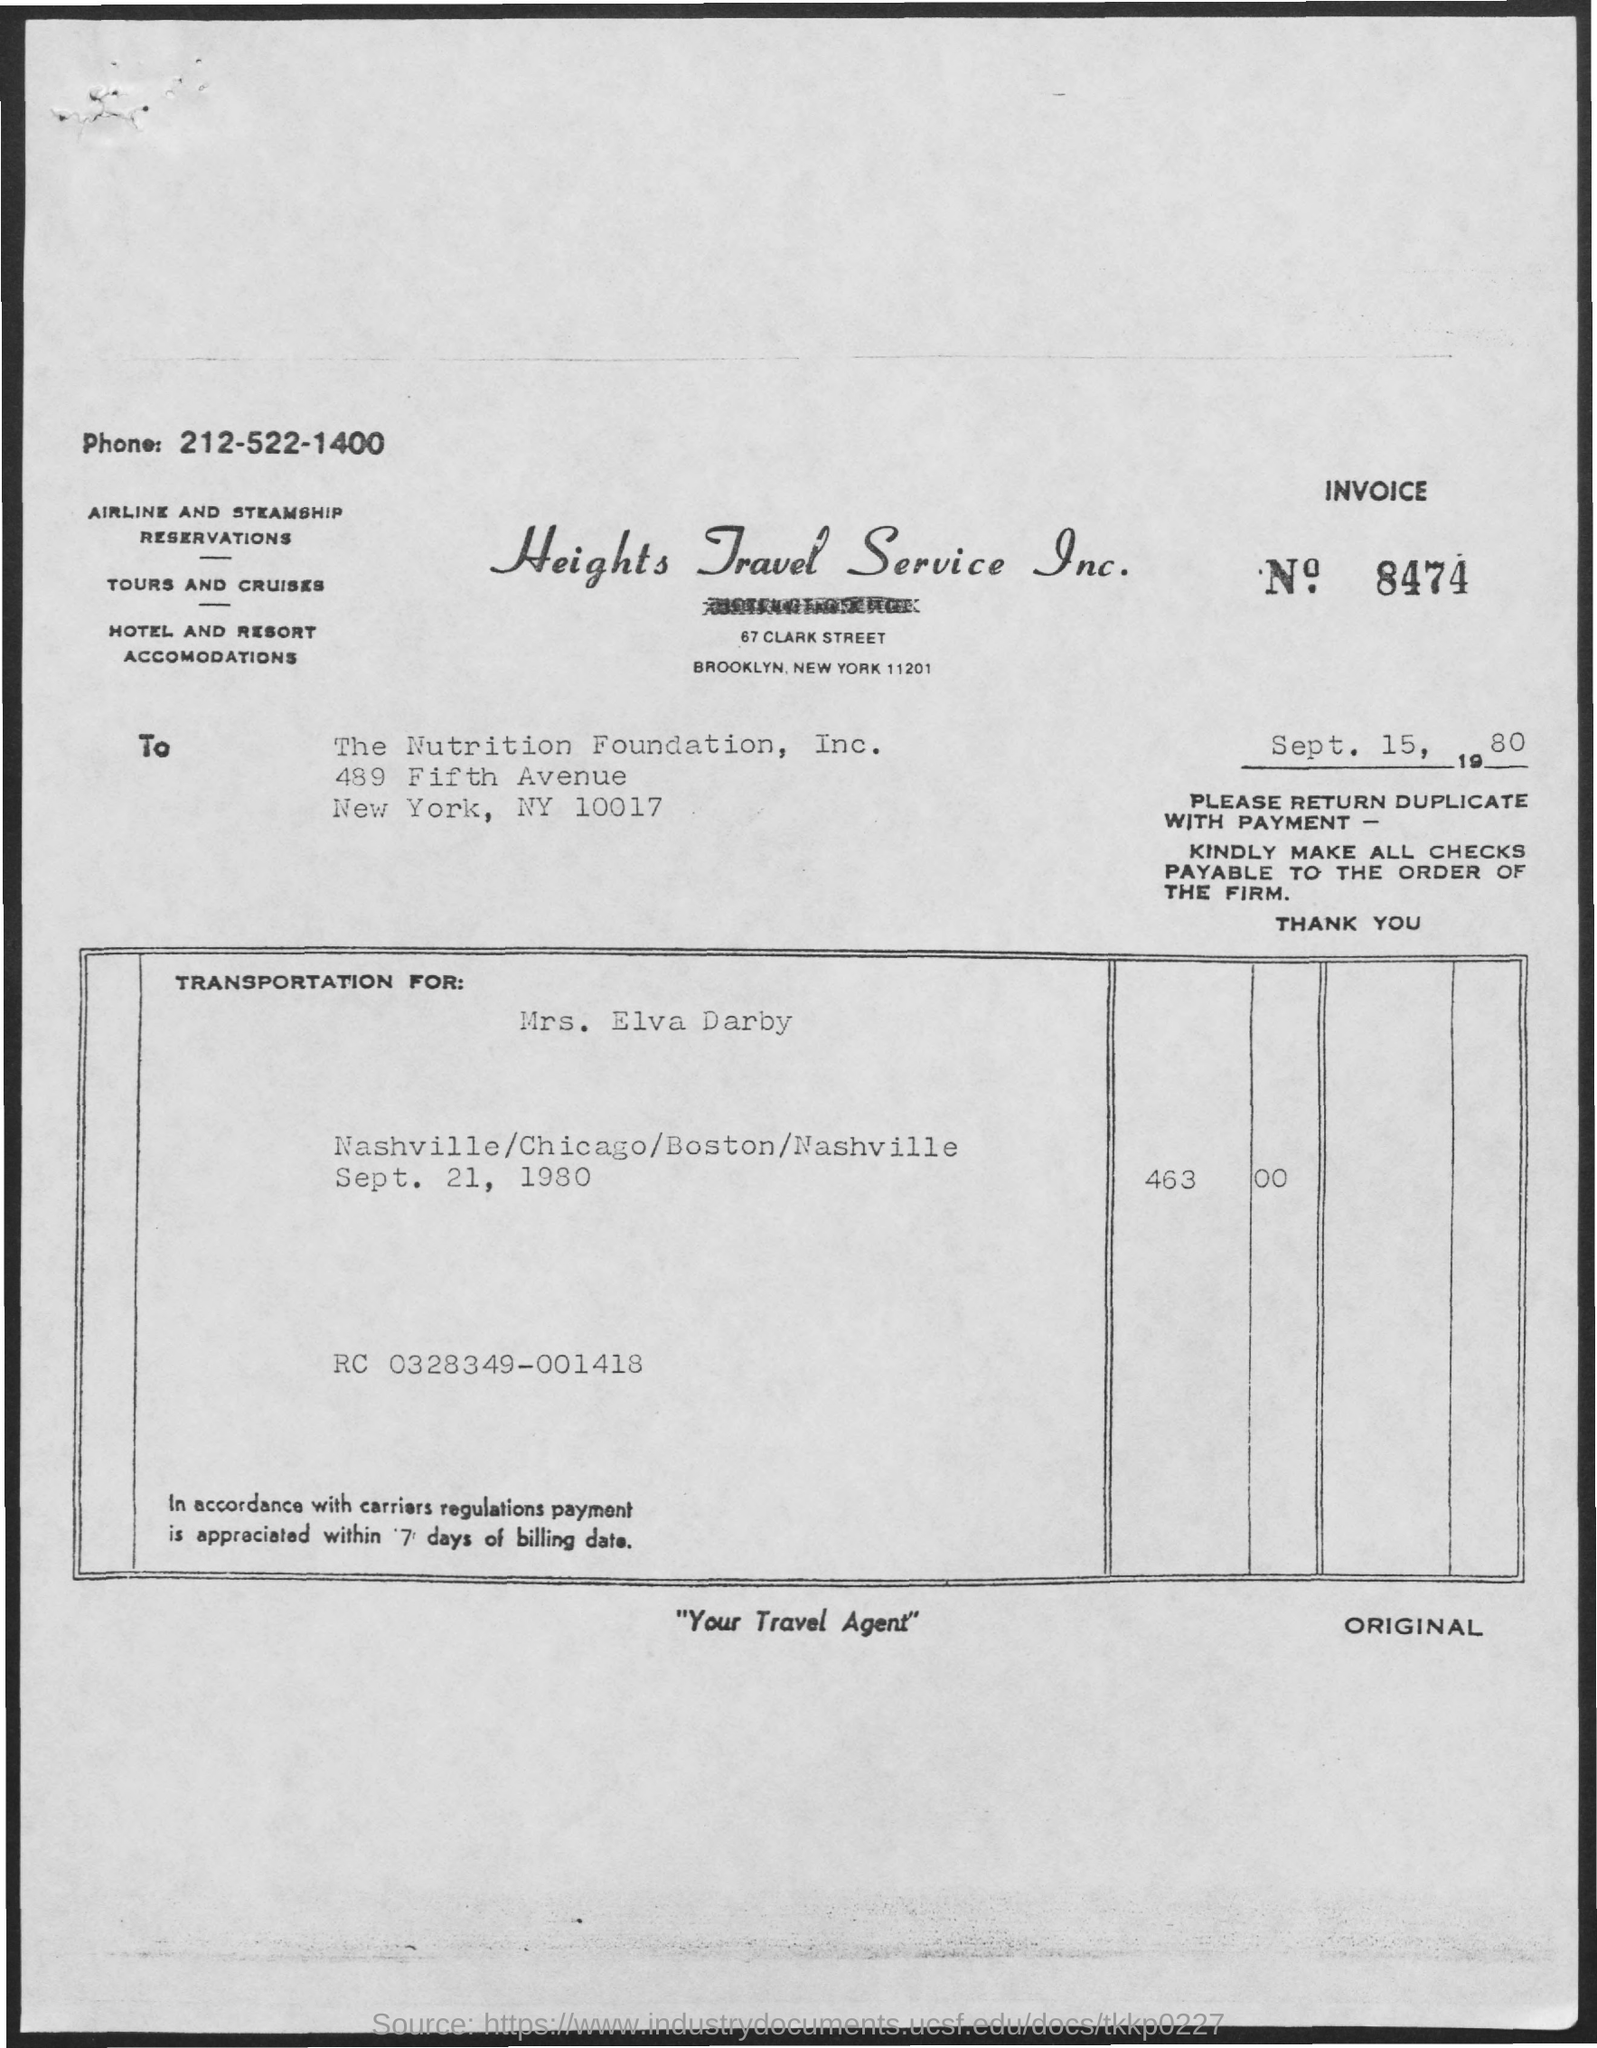What is the Invoice No.?
Offer a terse response. 8474. What is the title of the document?
Provide a short and direct response. Heights Travel Service Inc. What is the phone number mentioned in the document?
Your response must be concise. 212-522-1400. 